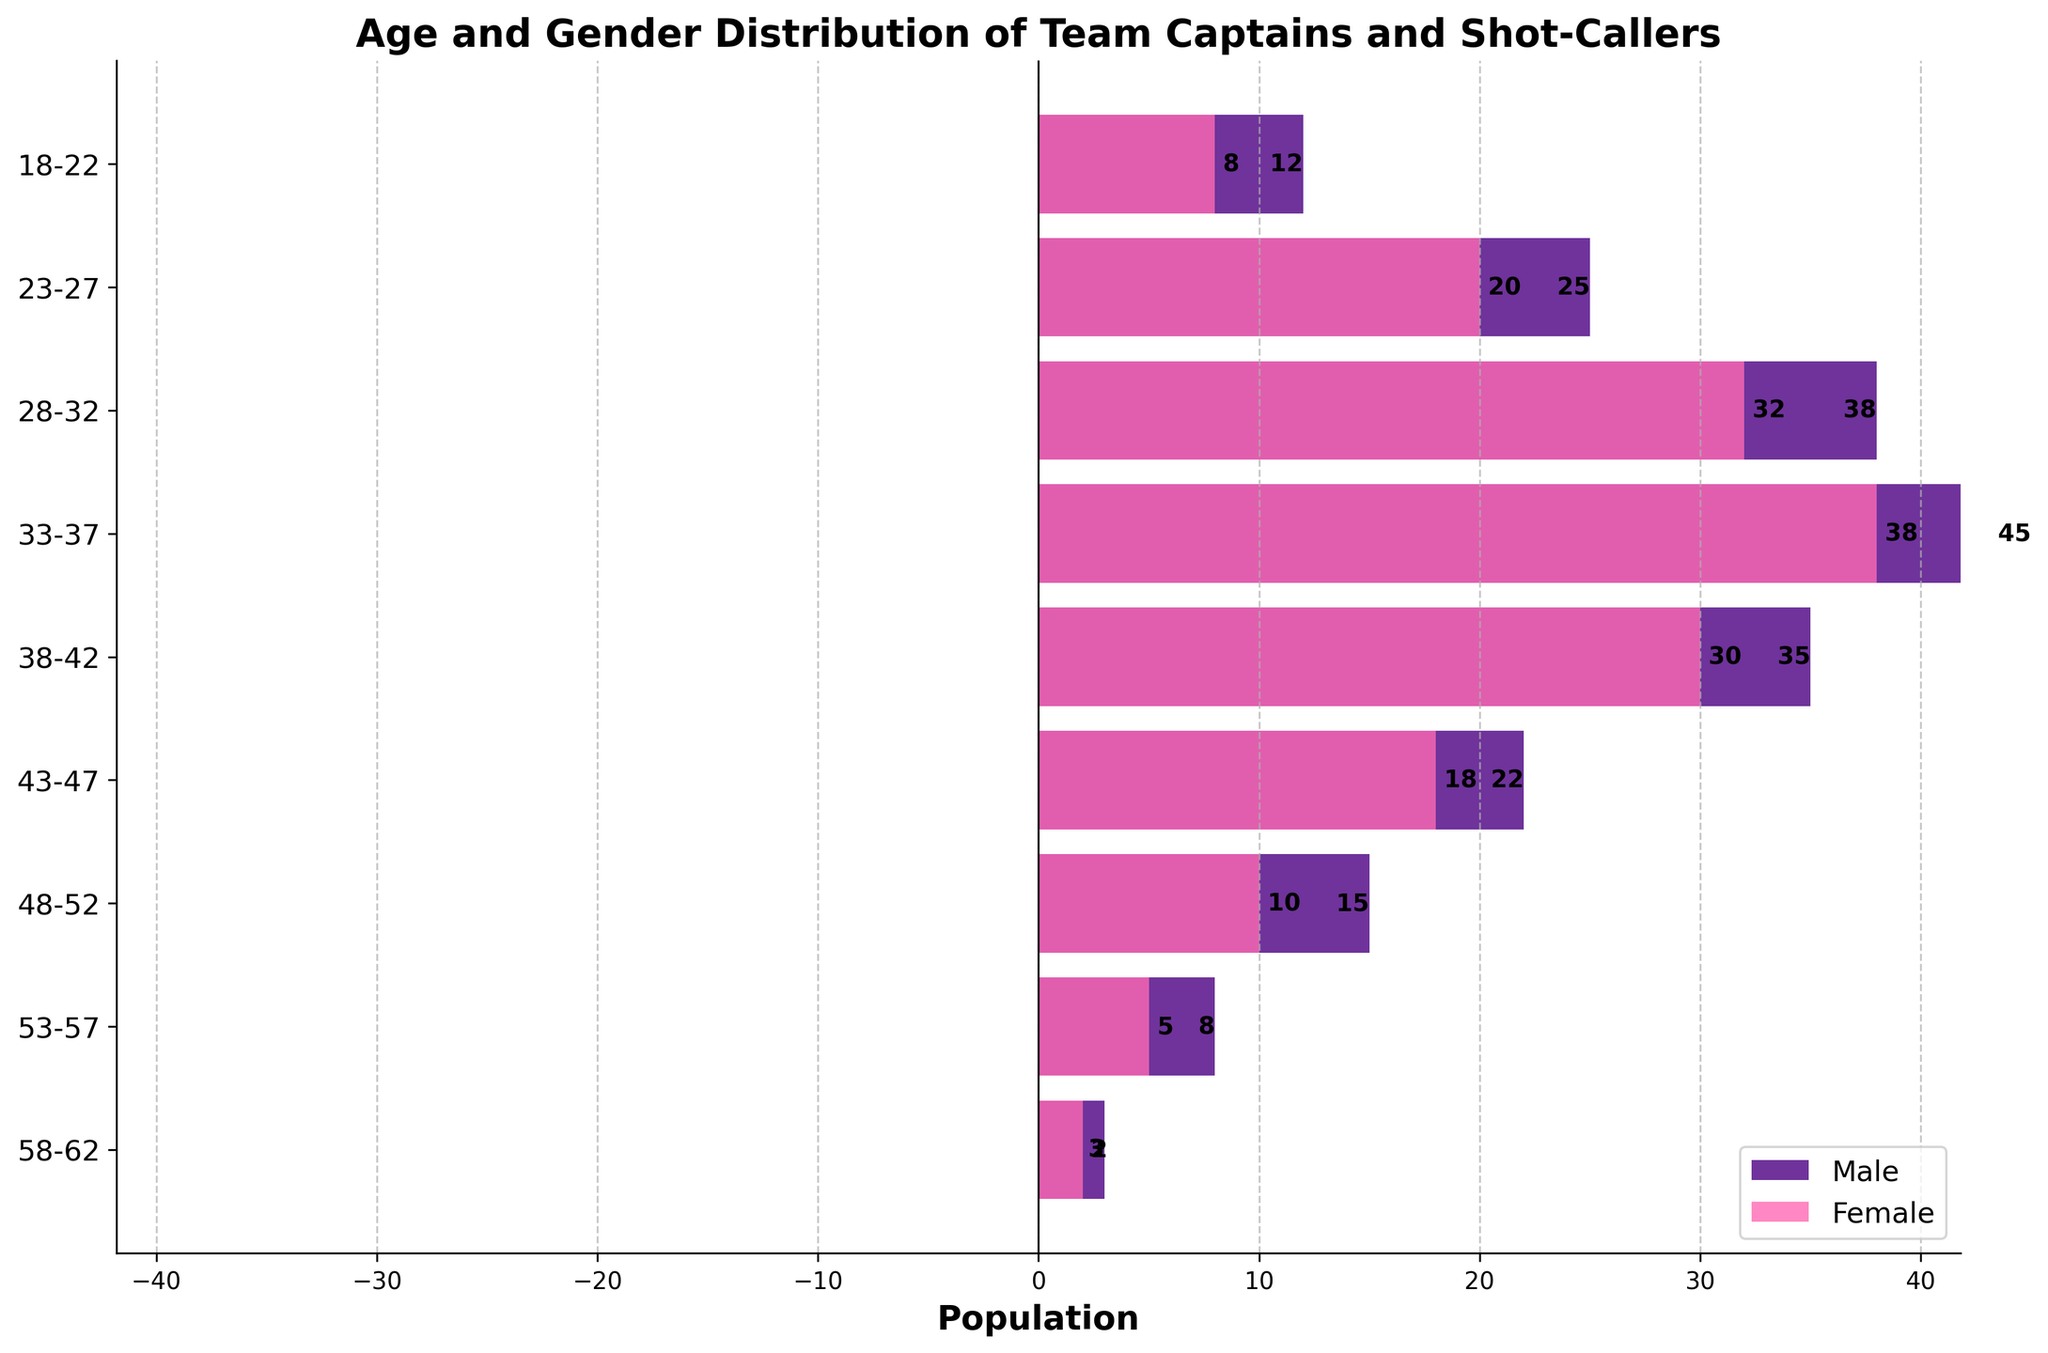what is the title of the figure? The title of the figure is displayed at the top of the chart and provides a summary of what the graph is about. In this case, the title describes both the age and gender distribution of team captains and shot-callers.
Answer: Age and Gender Distribution of Team Captains and Shot-Callers How many age groups are shown on the figure? The figure displays various horizontal bars representing different age categories. Each bar corresponds to one age group. By counting the number of bars, we can determine the number of age groups.
Answer: 9 Which age group has the highest number of female team captains and shot-callers? To find the age group with the highest number of female team captains and shot-callers, look for the longest pink (female) bar on the right side of the graph. The age group corresponding to this bar is our answer.
Answer: 33-37 Compare the male and female distributions for the 43-47 age group. Which gender has more team captains and shot-callers? For the 43-47 age group, examine the length of the bars for both males and females. The bar that extends the furthest from the centerline indicates the gender with a higher count in this age group.
Answer: Male What's the average number of female team captains and shot-callers in the 23-27, 28-32, and 33-37 age groups? To calculate the average, first find the values for female team captains and shot-callers in each age group: 20, 32, and 38. Add these values together and then divide by the number of age groups (3). (20 + 32 + 38) / 3 = 90 / 3 = 30
Answer: 30 What is the age group with the smallest number of female team captains and shot-callers? To identify the age group with the smallest number of females, look for the shortest pink bar on the right side of the chart. The label on this bar indicates the corresponding age group.
Answer: 58-62 How does the 18-22 age group's male population compare to its female population? Look at the lengths of the bars for the 18-22 age group on both sides of the centerline. The male bar is on the left and the female bar is on the right. Comparing the lengths shows that the male population is greater than the female population.
Answer: Male is greater What is the combined total number of male and female team captains and shot-callers in the 38-42 age group? First, find the values for both male and female team captains and shot-callers in the 38-42 age group. They are 35 (male) and 30 (female). Add these values together to get the total number. 35 + 30 = 65
Answer: 65 